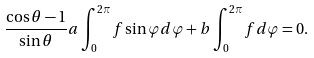Convert formula to latex. <formula><loc_0><loc_0><loc_500><loc_500>\frac { \cos \theta - 1 } { \sin \theta } a \int _ { 0 } ^ { 2 \pi } f \sin \varphi d \varphi + b \int _ { 0 } ^ { 2 \pi } f d \varphi = 0 .</formula> 